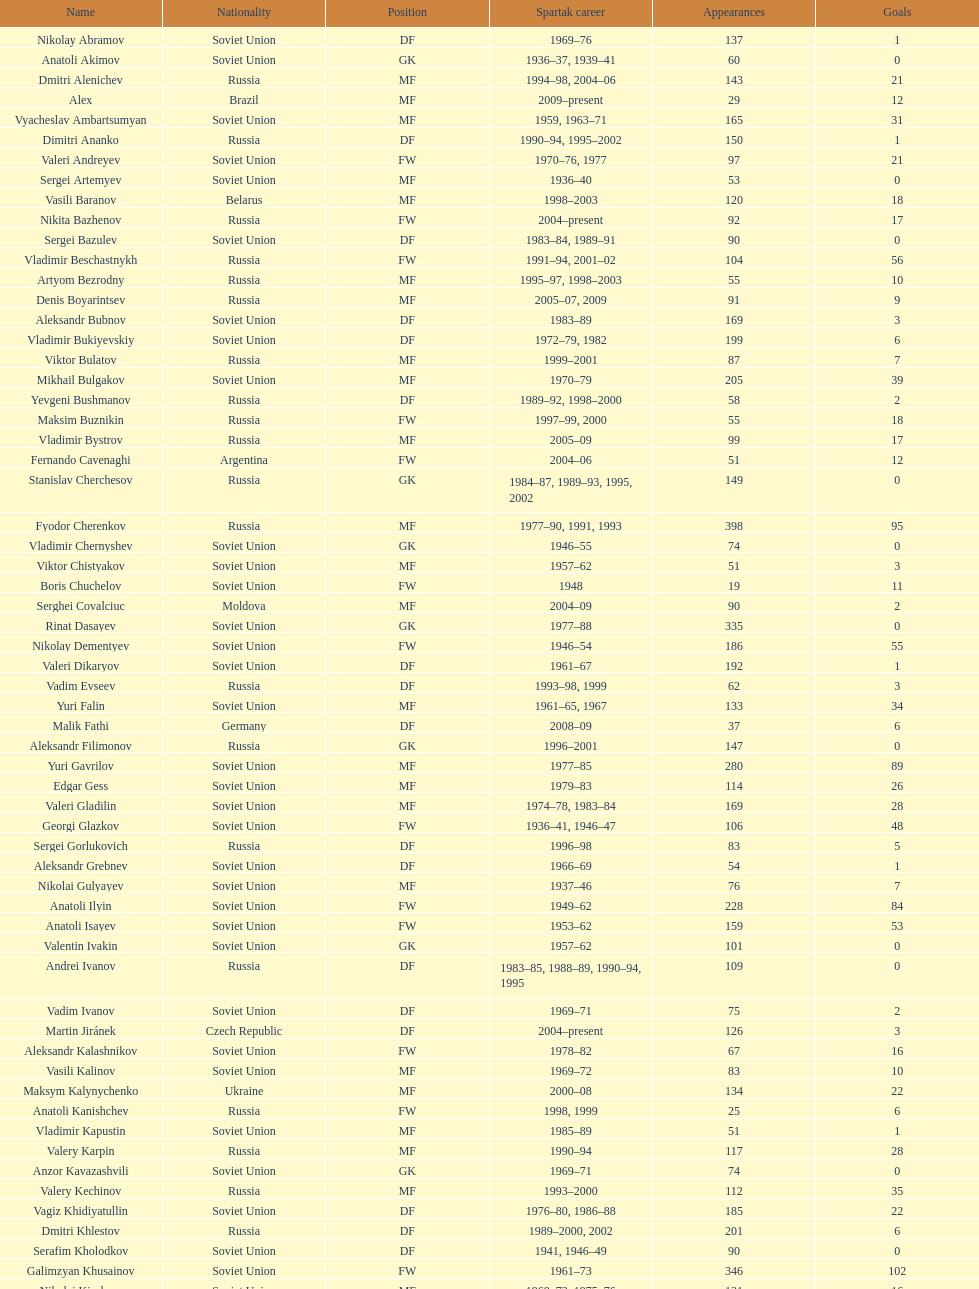Who has the greatest number of appearances to their name? Fyodor Cherenkov. 